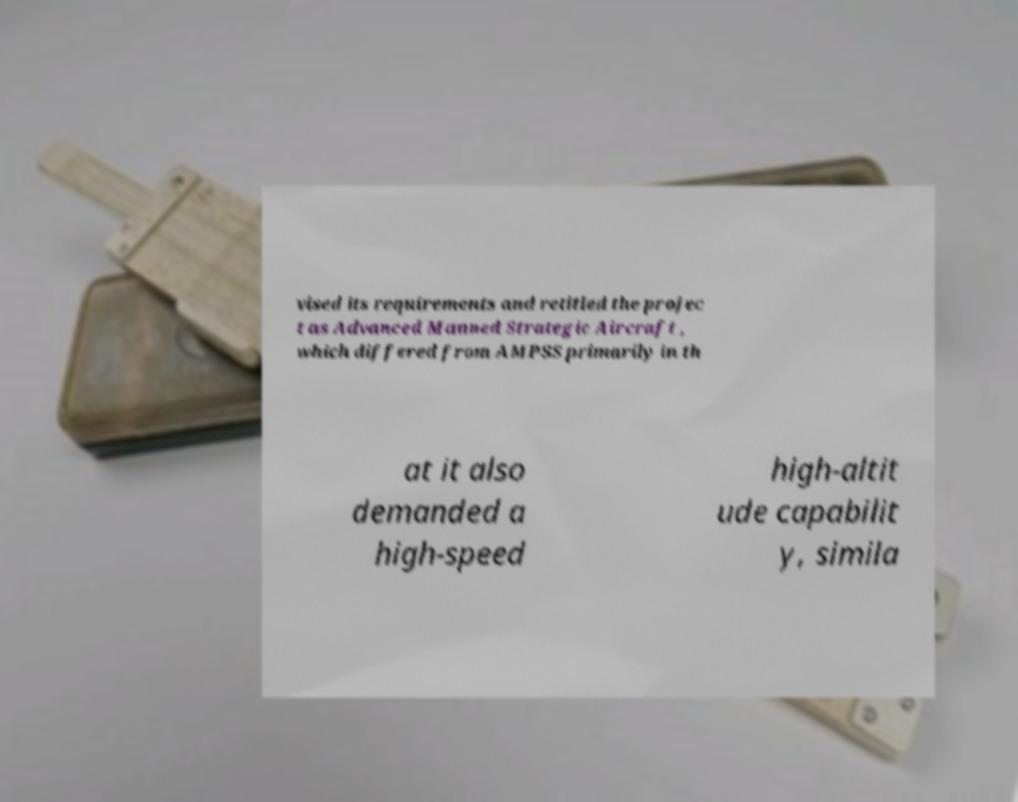Please identify and transcribe the text found in this image. vised its requirements and retitled the projec t as Advanced Manned Strategic Aircraft , which differed from AMPSS primarily in th at it also demanded a high-speed high-altit ude capabilit y, simila 